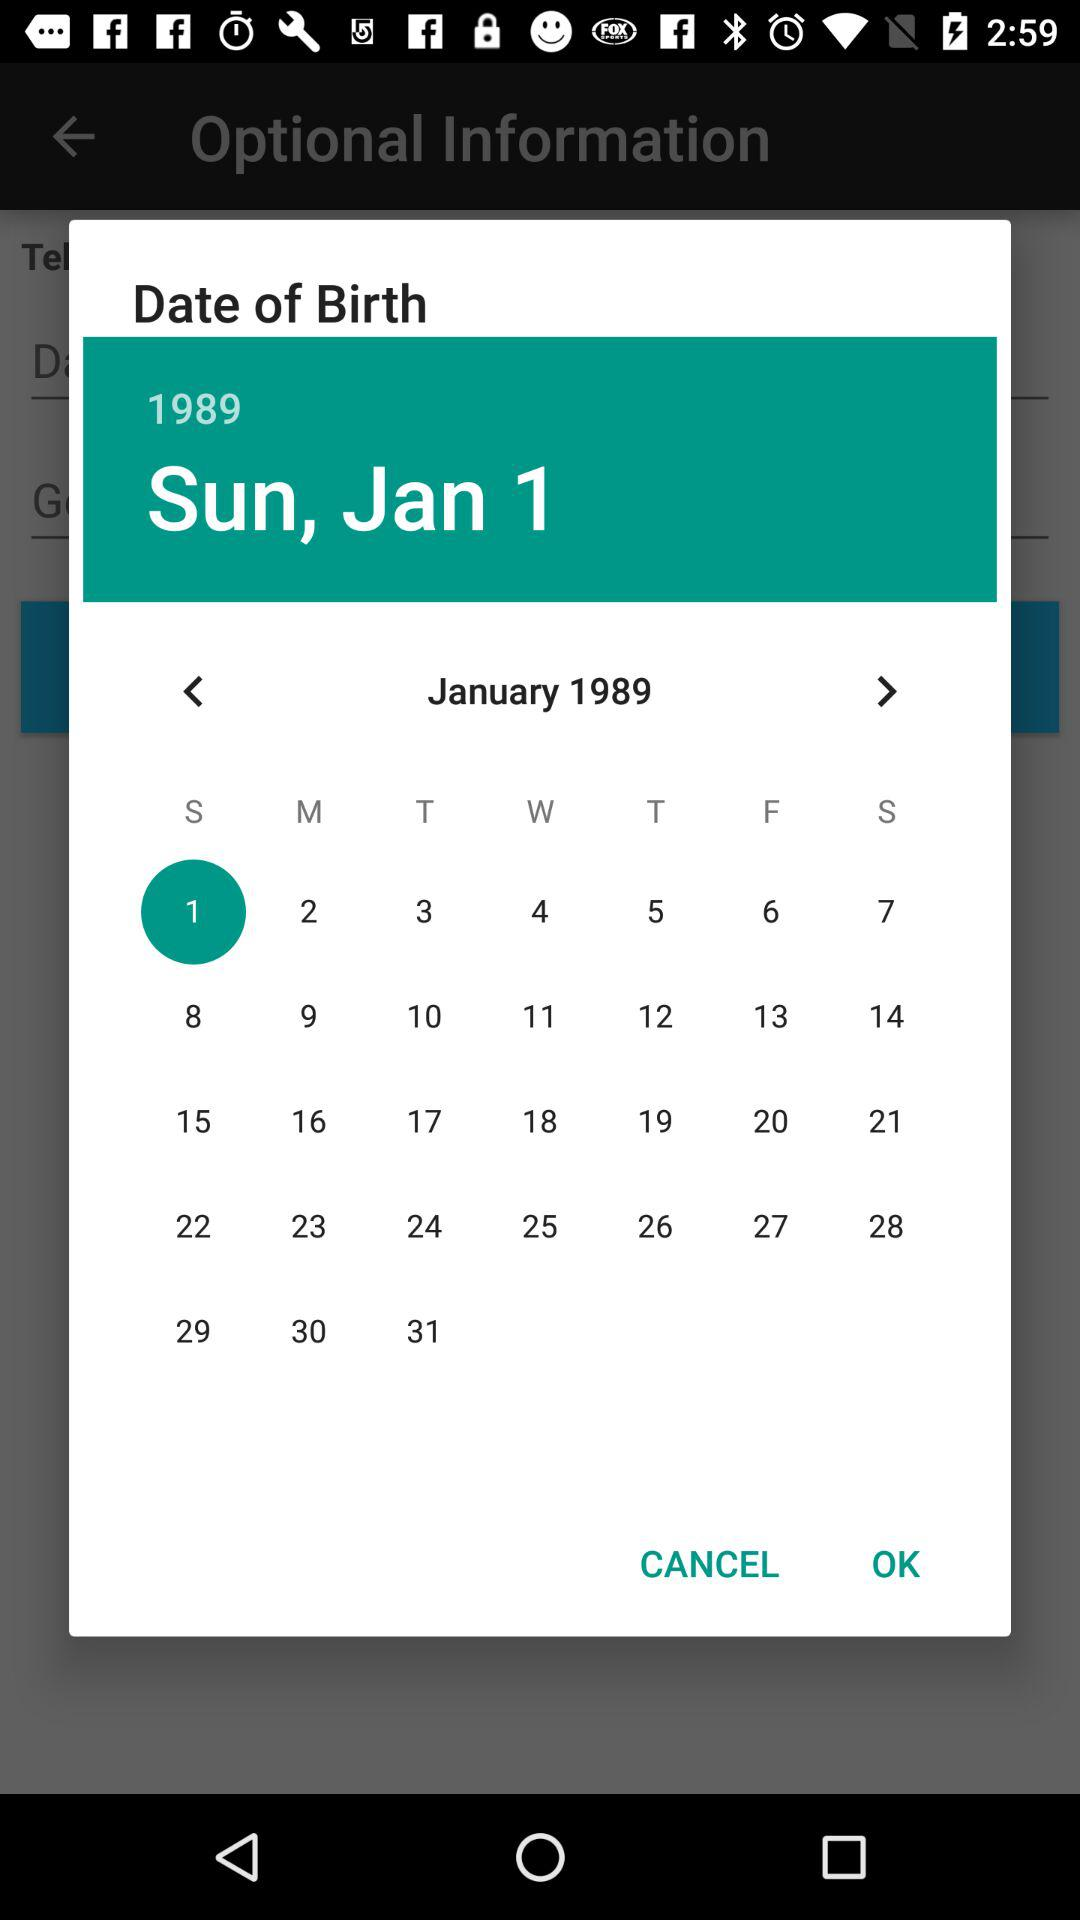What is the date of birth? The date of birth is Sunday, January 1, 1989. 